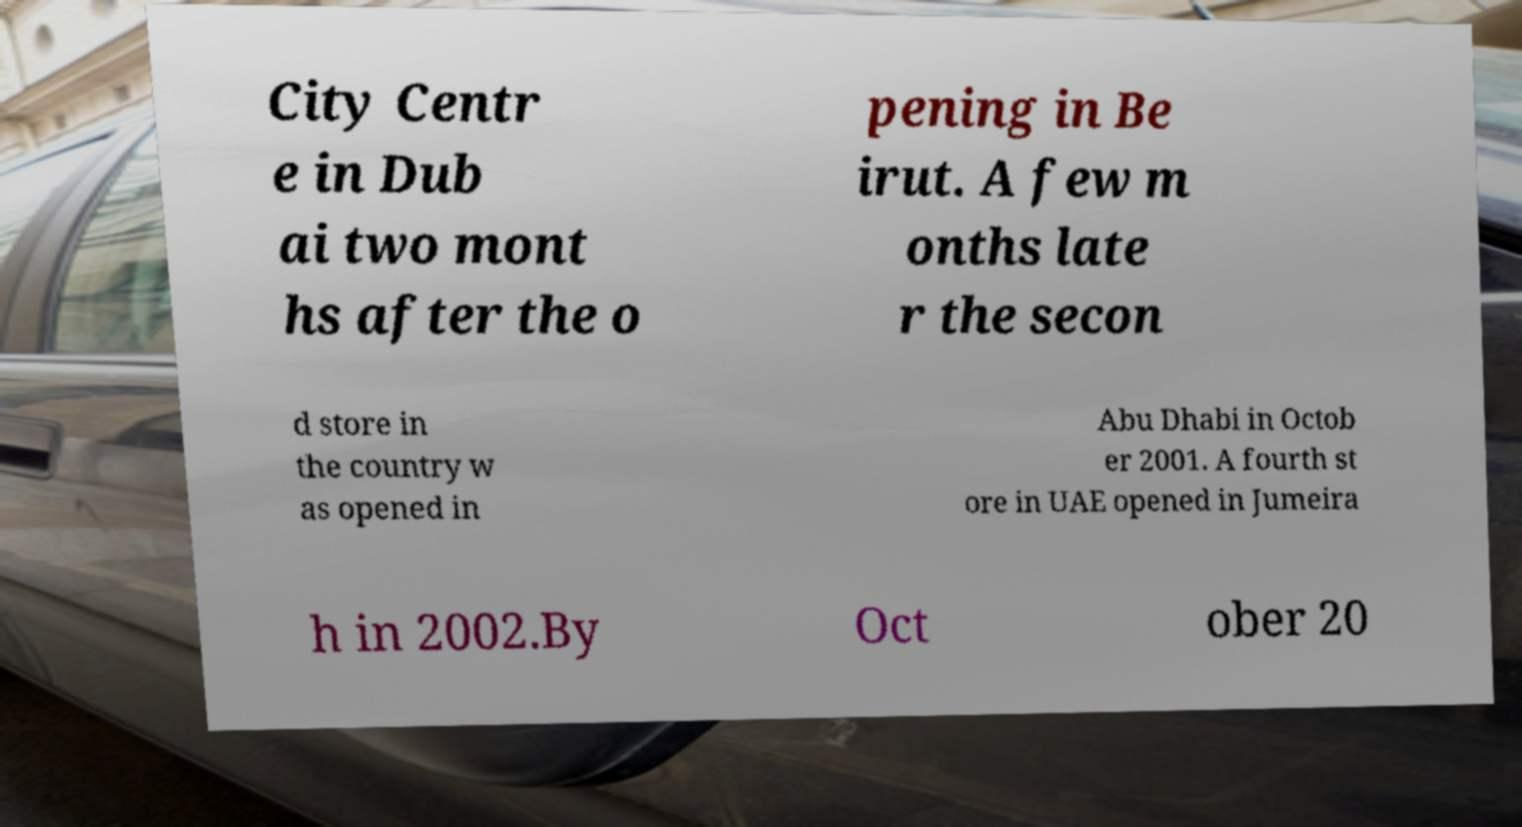What messages or text are displayed in this image? I need them in a readable, typed format. City Centr e in Dub ai two mont hs after the o pening in Be irut. A few m onths late r the secon d store in the country w as opened in Abu Dhabi in Octob er 2001. A fourth st ore in UAE opened in Jumeira h in 2002.By Oct ober 20 